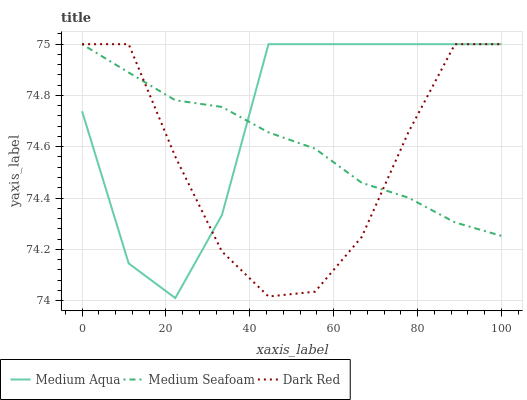Does Medium Seafoam have the minimum area under the curve?
Answer yes or no. No. Does Medium Seafoam have the maximum area under the curve?
Answer yes or no. No. Is Medium Aqua the smoothest?
Answer yes or no. No. Is Medium Seafoam the roughest?
Answer yes or no. No. Does Medium Seafoam have the lowest value?
Answer yes or no. No. 